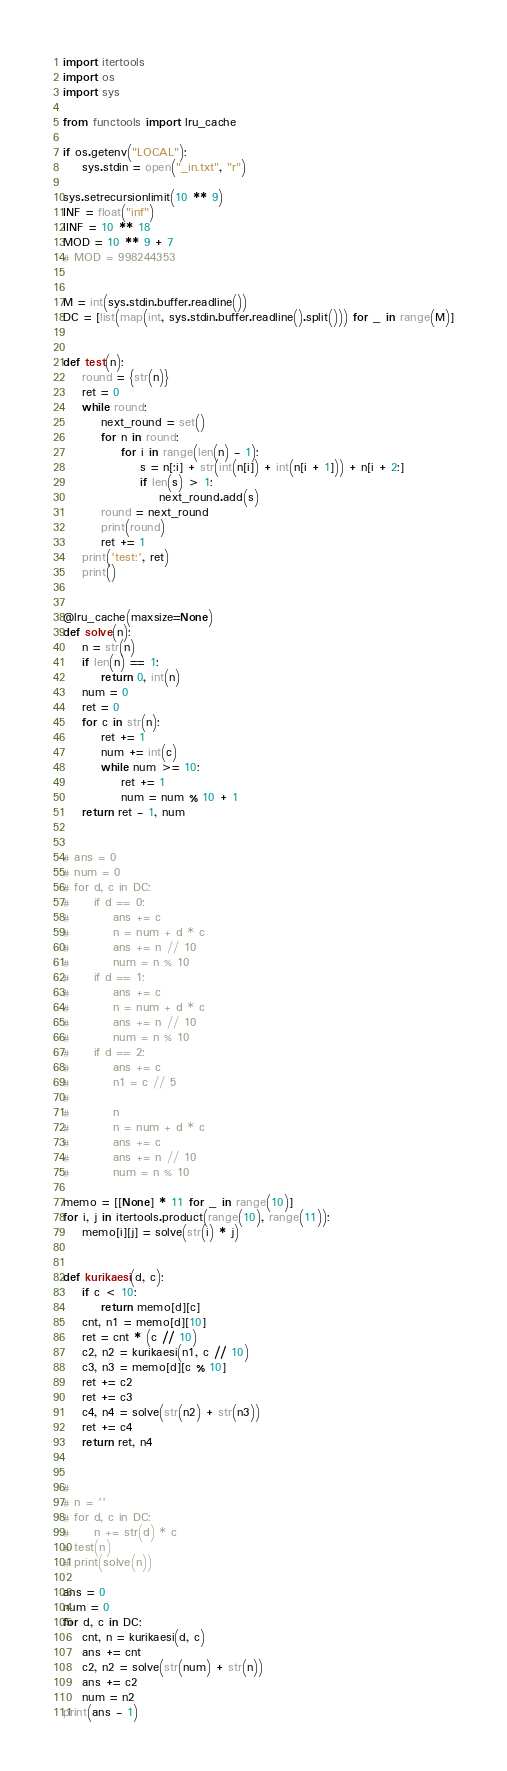<code> <loc_0><loc_0><loc_500><loc_500><_Python_>import itertools
import os
import sys

from functools import lru_cache

if os.getenv("LOCAL"):
    sys.stdin = open("_in.txt", "r")

sys.setrecursionlimit(10 ** 9)
INF = float("inf")
IINF = 10 ** 18
MOD = 10 ** 9 + 7
# MOD = 998244353


M = int(sys.stdin.buffer.readline())
DC = [list(map(int, sys.stdin.buffer.readline().split())) for _ in range(M)]


def test(n):
    round = {str(n)}
    ret = 0
    while round:
        next_round = set()
        for n in round:
            for i in range(len(n) - 1):
                s = n[:i] + str(int(n[i]) + int(n[i + 1])) + n[i + 2:]
                if len(s) > 1:
                    next_round.add(s)
        round = next_round
        print(round)
        ret += 1
    print('test:', ret)
    print()


@lru_cache(maxsize=None)
def solve(n):
    n = str(n)
    if len(n) == 1:
        return 0, int(n)
    num = 0
    ret = 0
    for c in str(n):
        ret += 1
        num += int(c)
        while num >= 10:
            ret += 1
            num = num % 10 + 1
    return ret - 1, num


# ans = 0
# num = 0
# for d, c in DC:
#     if d == 0:
#         ans += c
#         n = num + d * c
#         ans += n // 10
#         num = n % 10
#     if d == 1:
#         ans += c
#         n = num + d * c
#         ans += n // 10
#         num = n % 10
#     if d == 2:
#         ans += c
#         n1 = c // 5
#
#         n
#         n = num + d * c
#         ans += c
#         ans += n // 10
#         num = n % 10

memo = [[None] * 11 for _ in range(10)]
for i, j in itertools.product(range(10), range(11)):
    memo[i][j] = solve(str(i) * j)


def kurikaesi(d, c):
    if c < 10:
        return memo[d][c]
    cnt, n1 = memo[d][10]
    ret = cnt * (c // 10)
    c2, n2 = kurikaesi(n1, c // 10)
    c3, n3 = memo[d][c % 10]
    ret += c2
    ret += c3
    c4, n4 = solve(str(n2) + str(n3))
    ret += c4
    return ret, n4


#
# n = ''
# for d, c in DC:
#     n += str(d) * c
# test(n)
# print(solve(n))

ans = 0
num = 0
for d, c in DC:
    cnt, n = kurikaesi(d, c)
    ans += cnt
    c2, n2 = solve(str(num) + str(n))
    ans += c2
    num = n2
print(ans - 1)
</code> 